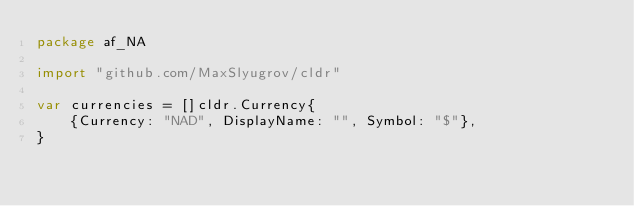<code> <loc_0><loc_0><loc_500><loc_500><_Go_>package af_NA

import "github.com/MaxSlyugrov/cldr"

var currencies = []cldr.Currency{
	{Currency: "NAD", DisplayName: "", Symbol: "$"},
}
</code> 